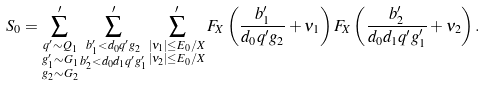Convert formula to latex. <formula><loc_0><loc_0><loc_500><loc_500>S _ { 0 } & = \sum ^ { \prime } _ { \substack { q ^ { \prime } \sim Q _ { 1 } \\ g _ { 1 } ^ { \prime } \sim G _ { 1 } \\ g _ { 2 } \sim G _ { 2 } } } \sum ^ { \prime } _ { \substack { b _ { 1 } ^ { \prime } < d _ { 0 } q ^ { \prime } g _ { 2 } \\ b _ { 2 } ^ { \prime } < d _ { 0 } d _ { 1 } q ^ { \prime } g _ { 1 } ^ { \prime } } } \sum ^ { \prime } _ { \substack { | \nu _ { 1 } | \leq E _ { 0 } / X \\ | \nu _ { 2 } | \leq E _ { 0 } / X } } F _ { X } \left ( \frac { b _ { 1 } ^ { \prime } } { d _ { 0 } q ^ { \prime } g _ { 2 } } + \nu _ { 1 } \right ) F _ { X } \left ( \frac { b _ { 2 } ^ { \prime } } { d _ { 0 } d _ { 1 } q ^ { \prime } g _ { 1 } ^ { \prime } } + \nu _ { 2 } \right ) .</formula> 